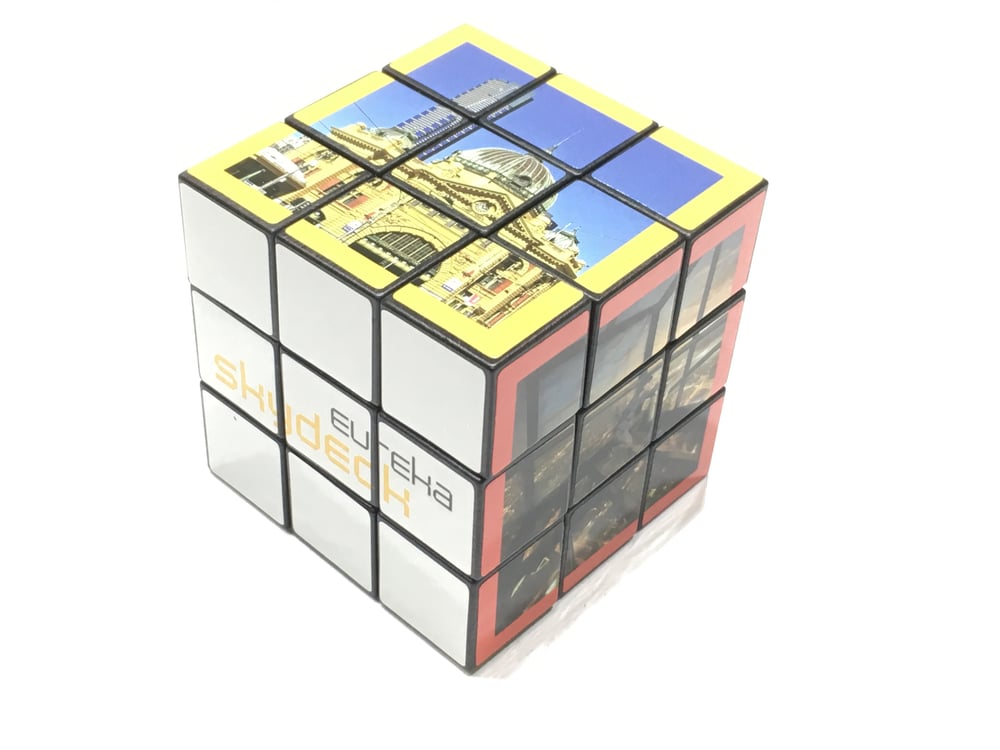How might the design on this cube inspire a new architectural project? The design on this cube, with its blend of grand domes, classical arches, and detailed facades, could inspire architects to create a new project that merges historical elegance with modern functionality. By studying the intricate details and structural harmony represented on the cube, architects might conceive a building that serves as a modern-day counterpart to these timeless structures. They could incorporate similar design elements but use contemporary materials and technologies to enhance sustainability and user experience. This project could become a landmark in its own right, paying homage to the past while addressing present and future needs. What modern-day structures share similarities with the building suggested by the cube, and how have they adapted classical designs for contemporary use? Modern-day structures like the United States Capitol Visitor Center, the Reichstag Dome in Berlin, and the British Museum's Great Court share similarities with the classical design elements suggested by the cube. These structures have adapted classical styles by incorporating elements such as domes and arches but have utilized modern materials like glass and steel to enhance light, space, and structural integrity. For instance, the Reichstag Dome combines traditional architecture with a modern glass dome, symbolizing transparency and democracy while providing panoramic views. Similarly, the British Museum's Great Court blends classical columns with a high-tech glass roof, creating a spacious and light-filled environment. Think of an imaginative scenario where the cube holds the secret to an architectural mystery. What could that mystery entail? In an imaginative scenario, the cube could hold the secret to an architectural mystery dating back centuries. Each segment, when aligned correctly, might reveal a part of a hidden map leading to an undiscovered ancient structure. Legend has it that this hidden structure contains blueprints to the world's first sustainable city, a marvel of engineering lost to time. Only those who can solve the cube and piece together the clues can unlock the final resting place of these blueprints, potentially revolutionizing modern architecture and city planning. 